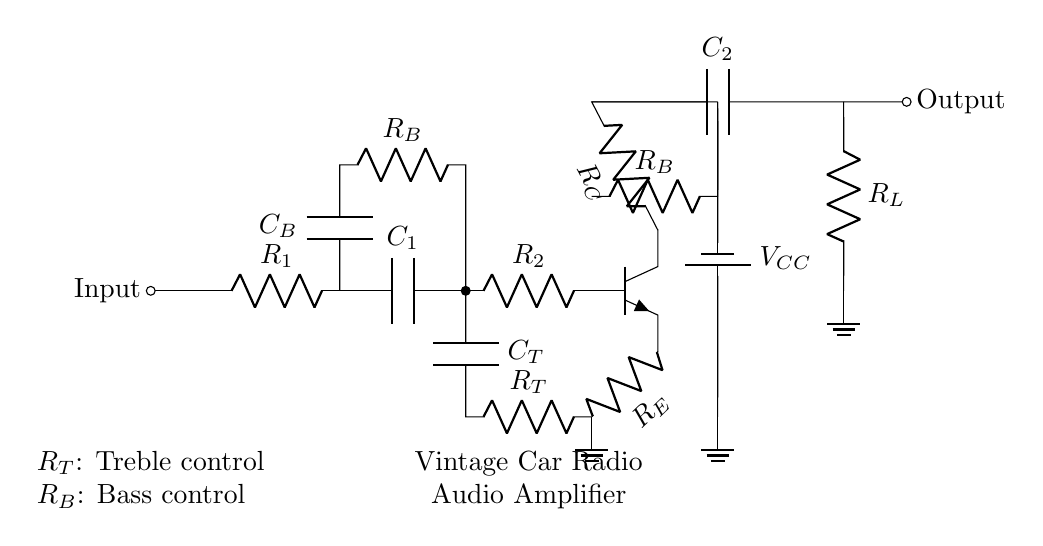What is the type of transistor used in the circuit? The circuit has an npn transistor, which is indicated by the npn label next to the symbol in the diagram.
Answer: npn What do the capacitors C1 and C2 assume in this circuit? Capacitor C1 is used for coupling, mainly for passing AC signals and blocking DC, while C2 is used to couple the amplified AC audio signal to the load.
Answer: Coupling What is the function of the resistor R_E in the circuit? Resistor R_E serves as the emitter resistor in the transistor amplifier configuration, helping to stabilize the biasing and improve linearity.
Answer: Bias stabilization What is the purpose of the low-pass filter (with components R_T and C_T)? The low-pass filter allows lower frequency signals to pass through while attenuating higher frequency signals, enabling treble control for sound quality adjustment.
Answer: Treble control What voltage does this circuit use as a power supply? The circuit uses V_CC as its power supply, which is indicated by the battery label above the connection in the circuit diagram.
Answer: V_CC Which component is responsible for controlling bass in the circuit? The resistor R_B alongside the capacitor C_B is responsible for controlling the bass frequencies within the audio signal.
Answer: R_B 